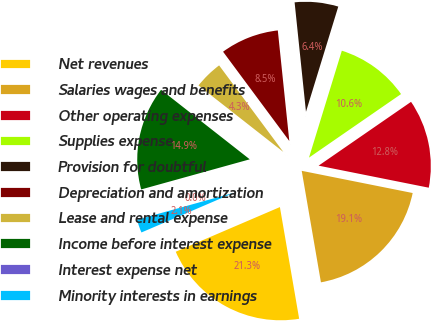Convert chart to OTSL. <chart><loc_0><loc_0><loc_500><loc_500><pie_chart><fcel>Net revenues<fcel>Salaries wages and benefits<fcel>Other operating expenses<fcel>Supplies expense<fcel>Provision for doubtful<fcel>Depreciation and amortization<fcel>Lease and rental expense<fcel>Income before interest expense<fcel>Interest expense net<fcel>Minority interests in earnings<nl><fcel>21.27%<fcel>19.14%<fcel>12.76%<fcel>10.64%<fcel>6.39%<fcel>8.51%<fcel>4.26%<fcel>14.89%<fcel>0.01%<fcel>2.13%<nl></chart> 